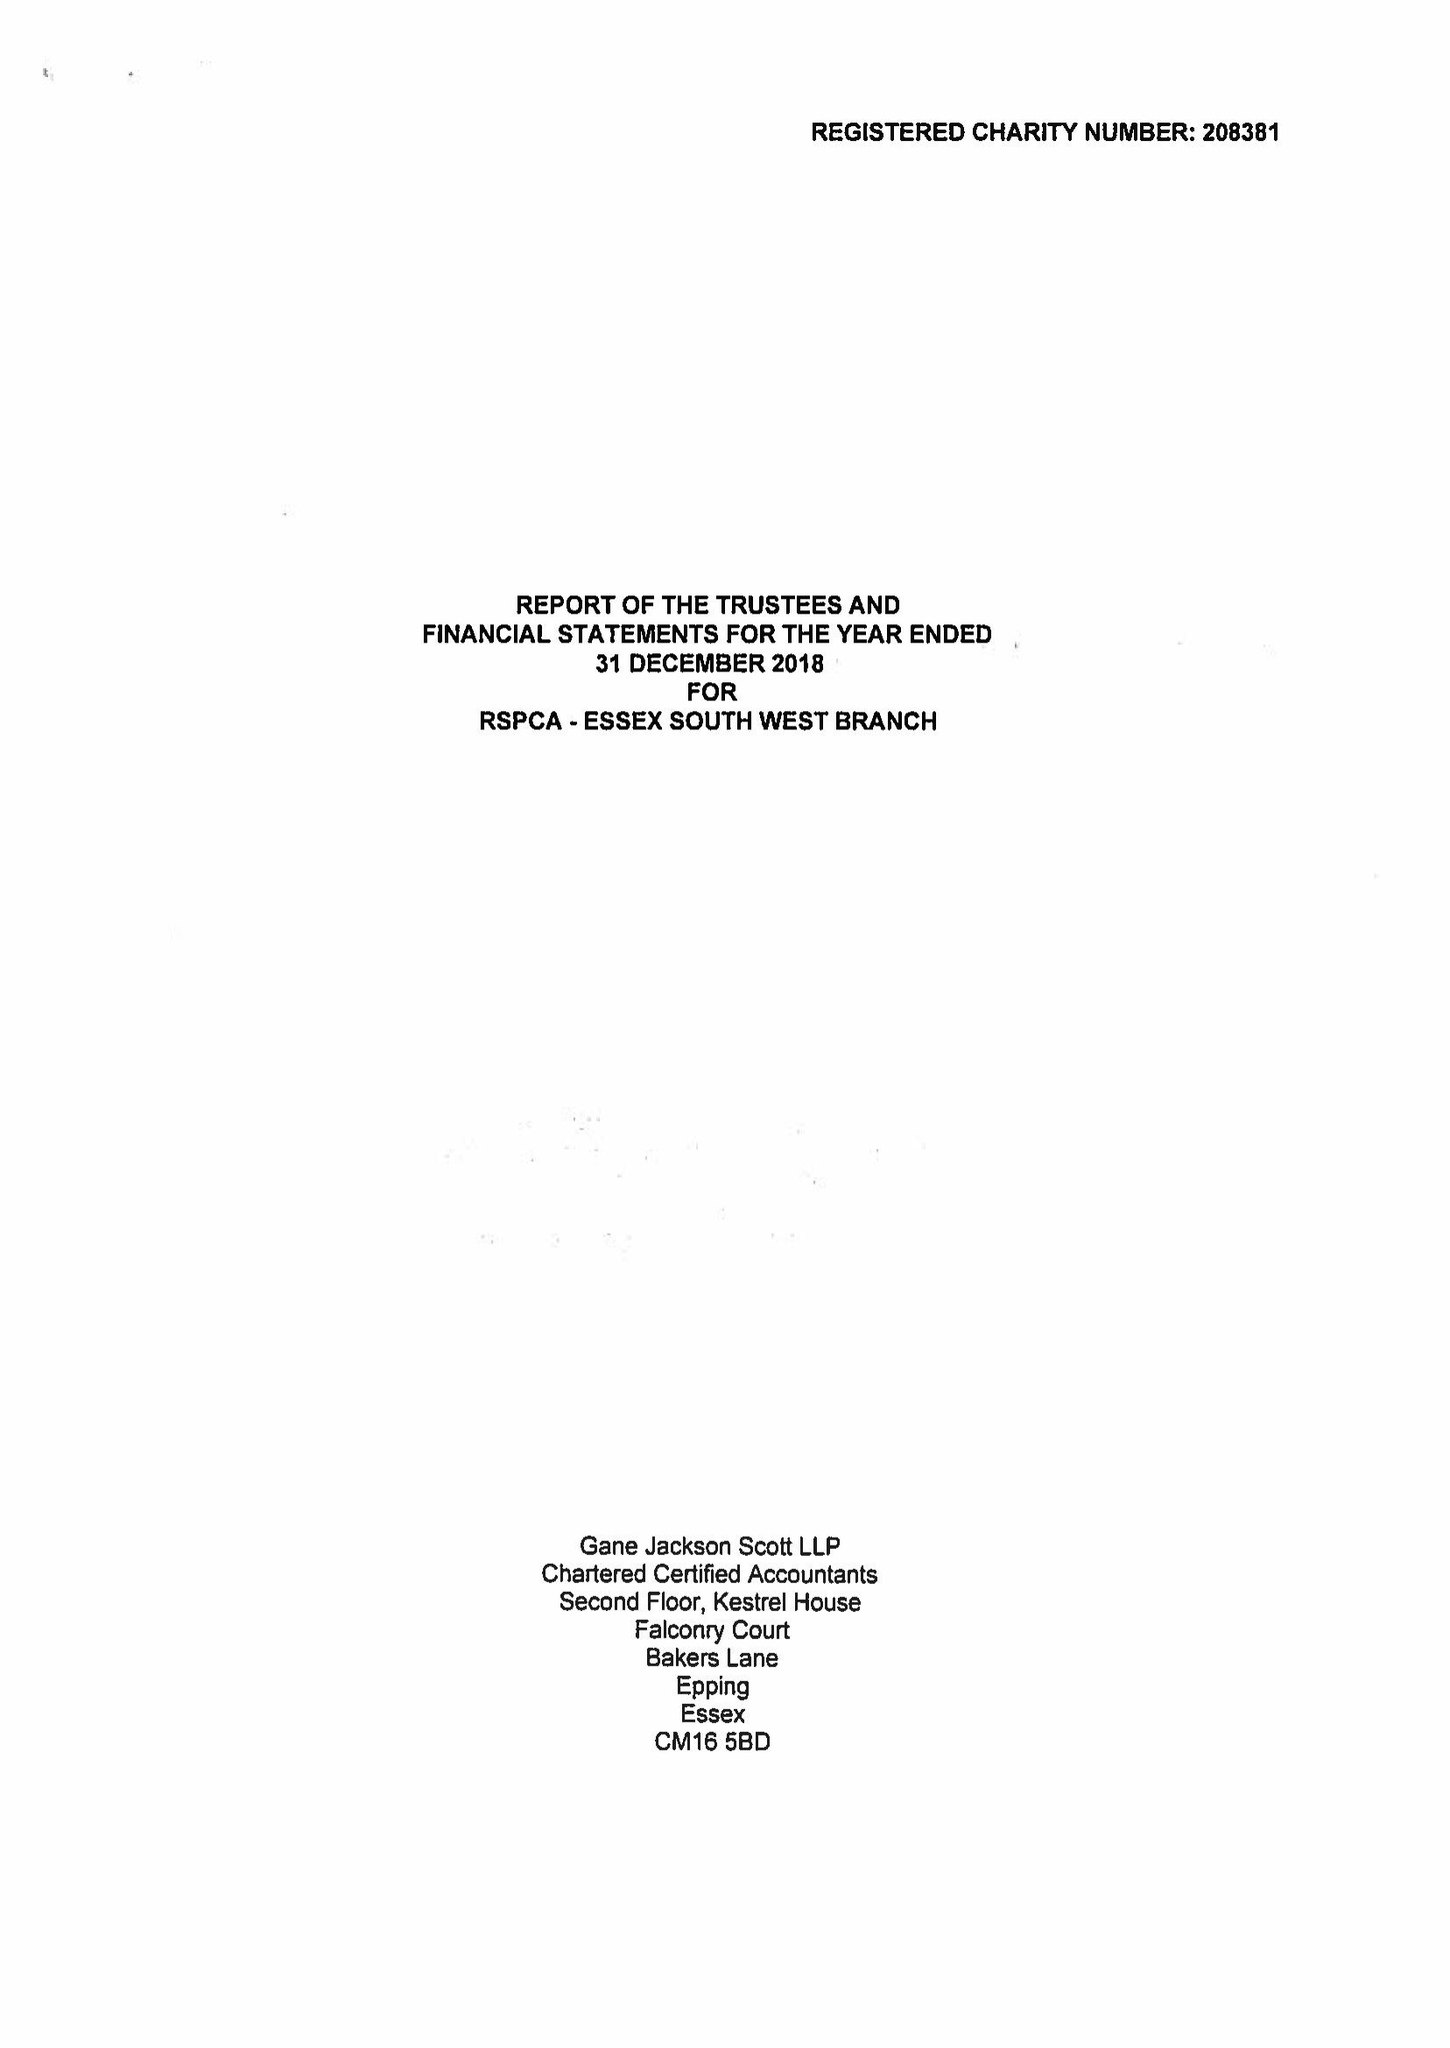What is the value for the address__post_town?
Answer the question using a single word or phrase. CHIGWELL 